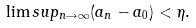Convert formula to latex. <formula><loc_0><loc_0><loc_500><loc_500>\lim s u p _ { n \rightarrow \infty } ( a _ { n } - a _ { 0 } ) < \eta .</formula> 